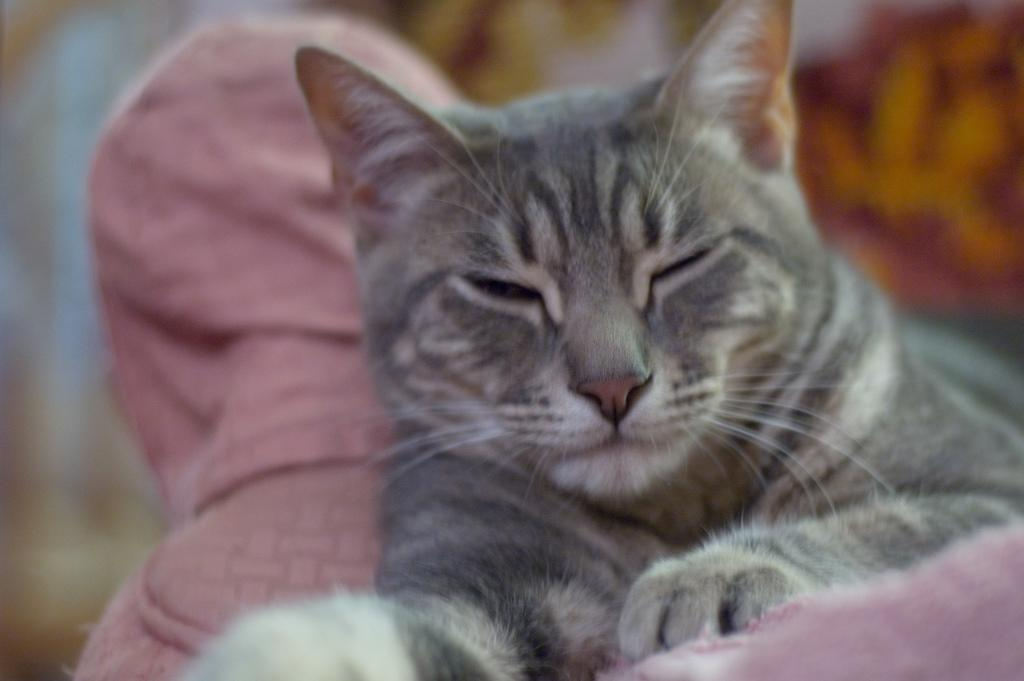What type of animal is in the image? There is a cat in the image. Can you describe the background of the image? The background of the image is blurred. What type of copper treatment is the cat undergoing in the image? There is no copper treatment or any reference to copper in the image; it simply features a cat with a blurred background. 